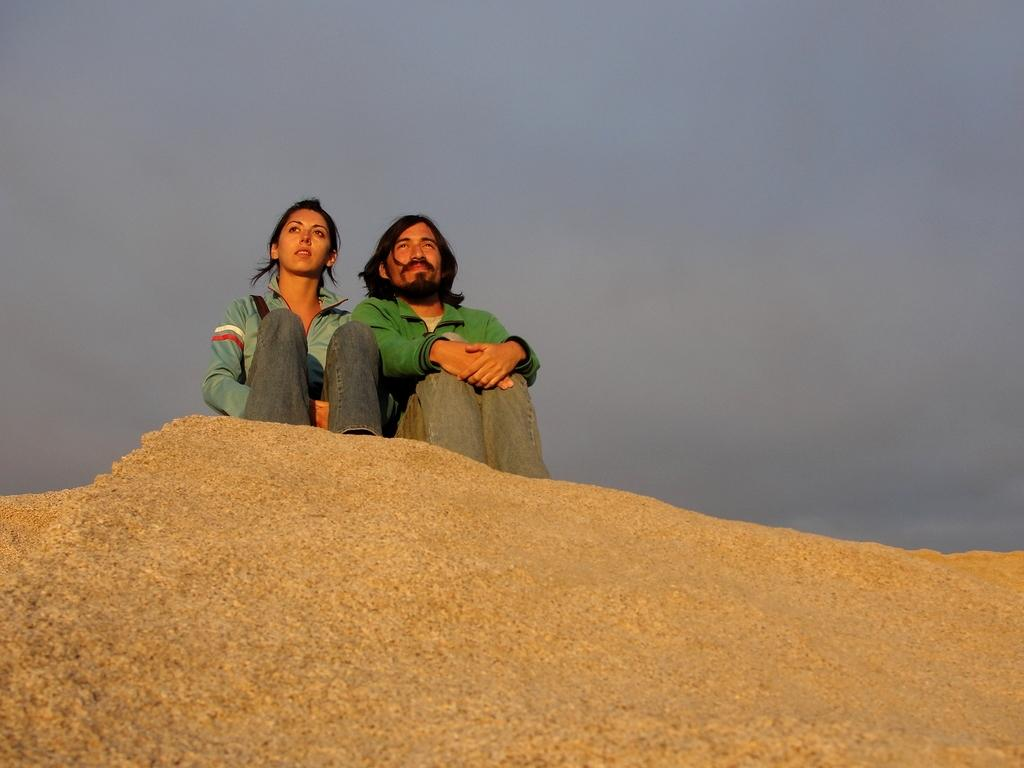What are the two people in the image doing? The woman and man in the image are sitting. Can you describe the gender of the two people in the image? There is a woman and a man in the image. What is visible in the background of the image? There is a sky visible in the background of the image. What is the name of the house where the woman gave birth to the man in the image? There is no information about the woman giving birth to the man in the image, nor is there any reference to a house. 